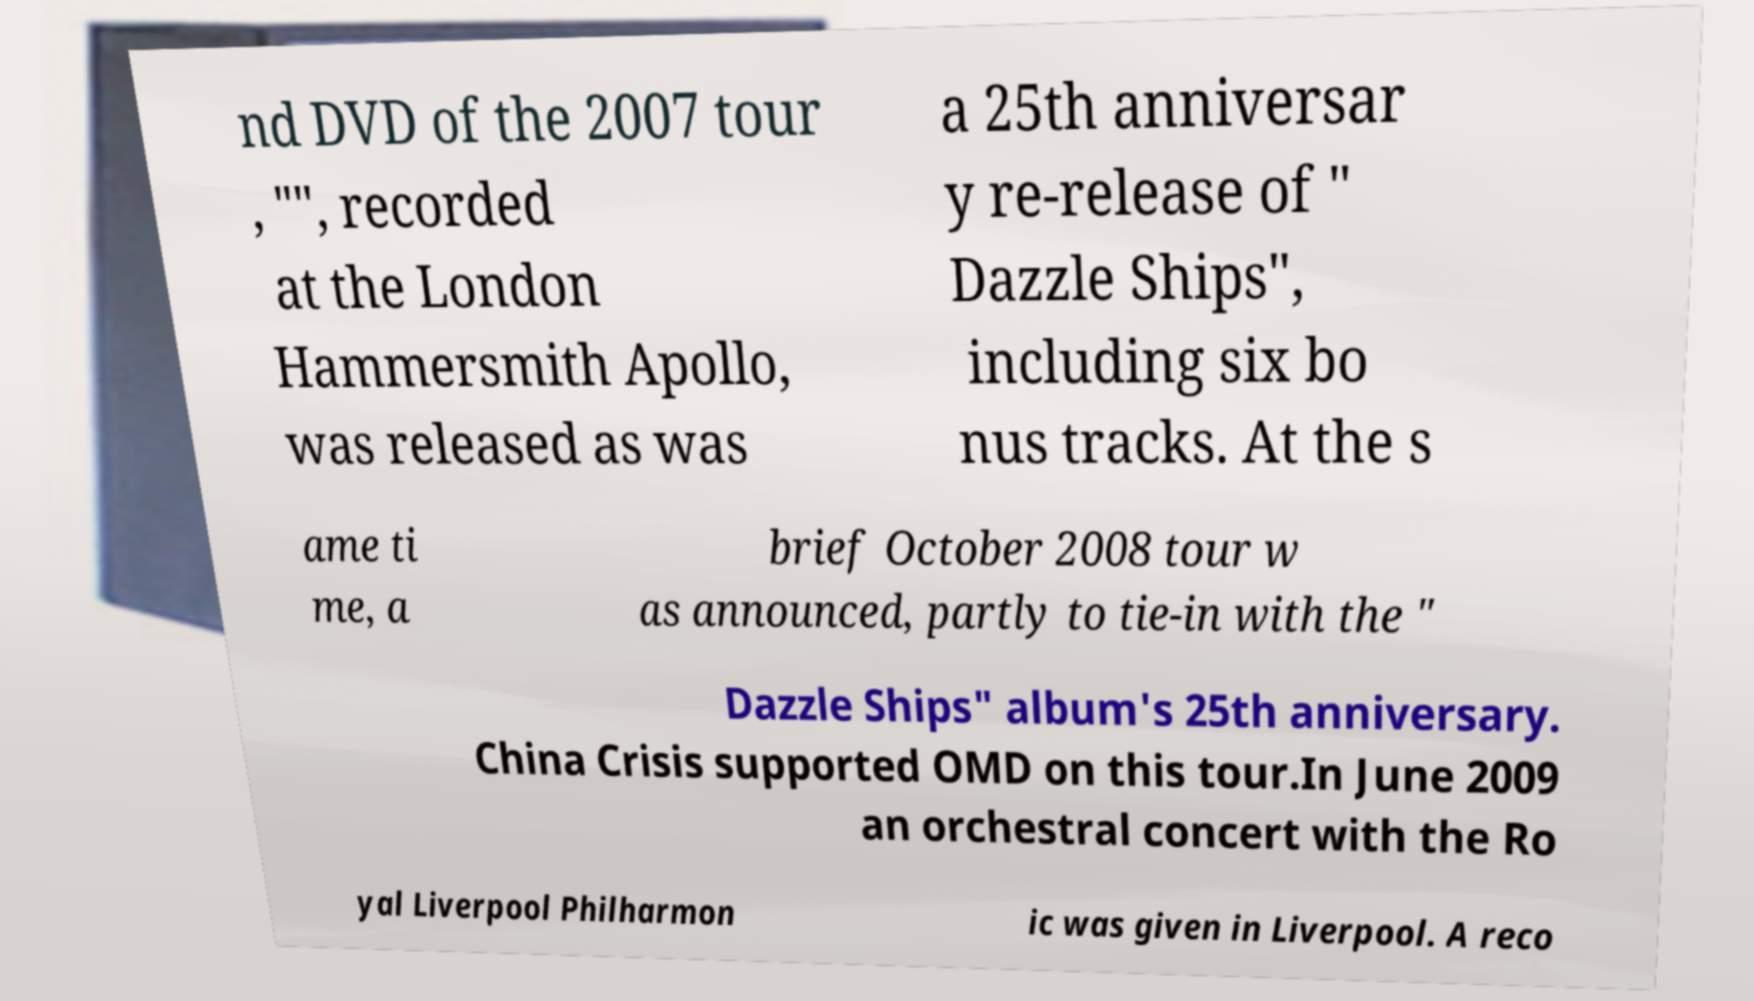Could you extract and type out the text from this image? nd DVD of the 2007 tour , "", recorded at the London Hammersmith Apollo, was released as was a 25th anniversar y re-release of " Dazzle Ships", including six bo nus tracks. At the s ame ti me, a brief October 2008 tour w as announced, partly to tie-in with the " Dazzle Ships" album's 25th anniversary. China Crisis supported OMD on this tour.In June 2009 an orchestral concert with the Ro yal Liverpool Philharmon ic was given in Liverpool. A reco 